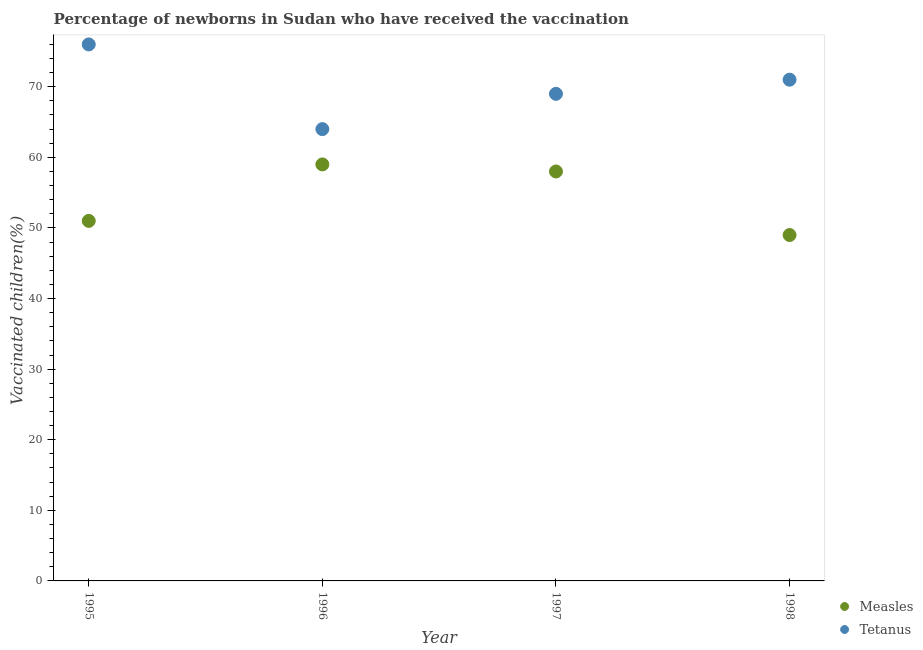Is the number of dotlines equal to the number of legend labels?
Offer a very short reply. Yes. What is the percentage of newborns who received vaccination for measles in 1997?
Make the answer very short. 58. Across all years, what is the maximum percentage of newborns who received vaccination for tetanus?
Give a very brief answer. 76. Across all years, what is the minimum percentage of newborns who received vaccination for tetanus?
Keep it short and to the point. 64. What is the total percentage of newborns who received vaccination for measles in the graph?
Your answer should be very brief. 217. What is the difference between the percentage of newborns who received vaccination for tetanus in 1995 and that in 1997?
Make the answer very short. 7. What is the difference between the percentage of newborns who received vaccination for tetanus in 1997 and the percentage of newborns who received vaccination for measles in 1998?
Offer a very short reply. 20. What is the average percentage of newborns who received vaccination for tetanus per year?
Offer a terse response. 70. In the year 1996, what is the difference between the percentage of newborns who received vaccination for measles and percentage of newborns who received vaccination for tetanus?
Ensure brevity in your answer.  -5. What is the ratio of the percentage of newborns who received vaccination for tetanus in 1997 to that in 1998?
Your answer should be compact. 0.97. Is the percentage of newborns who received vaccination for measles in 1995 less than that in 1998?
Provide a succinct answer. No. Is the difference between the percentage of newborns who received vaccination for tetanus in 1996 and 1998 greater than the difference between the percentage of newborns who received vaccination for measles in 1996 and 1998?
Your answer should be compact. No. What is the difference between the highest and the second highest percentage of newborns who received vaccination for measles?
Make the answer very short. 1. What is the difference between the highest and the lowest percentage of newborns who received vaccination for measles?
Give a very brief answer. 10. Is the percentage of newborns who received vaccination for tetanus strictly less than the percentage of newborns who received vaccination for measles over the years?
Offer a very short reply. No. How many years are there in the graph?
Provide a succinct answer. 4. Are the values on the major ticks of Y-axis written in scientific E-notation?
Your answer should be very brief. No. Where does the legend appear in the graph?
Your answer should be very brief. Bottom right. What is the title of the graph?
Offer a terse response. Percentage of newborns in Sudan who have received the vaccination. Does "Exports" appear as one of the legend labels in the graph?
Keep it short and to the point. No. What is the label or title of the X-axis?
Offer a terse response. Year. What is the label or title of the Y-axis?
Make the answer very short. Vaccinated children(%)
. What is the Vaccinated children(%)
 of Measles in 1995?
Offer a terse response. 51. What is the Vaccinated children(%)
 in Measles in 1996?
Ensure brevity in your answer.  59. What is the total Vaccinated children(%)
 of Measles in the graph?
Your response must be concise. 217. What is the total Vaccinated children(%)
 in Tetanus in the graph?
Keep it short and to the point. 280. What is the difference between the Vaccinated children(%)
 of Tetanus in 1995 and that in 1996?
Give a very brief answer. 12. What is the difference between the Vaccinated children(%)
 of Measles in 1995 and that in 1997?
Your answer should be compact. -7. What is the difference between the Vaccinated children(%)
 in Measles in 1995 and that in 1998?
Give a very brief answer. 2. What is the difference between the Vaccinated children(%)
 of Tetanus in 1996 and that in 1997?
Your answer should be compact. -5. What is the difference between the Vaccinated children(%)
 in Measles in 1996 and that in 1998?
Your response must be concise. 10. What is the difference between the Vaccinated children(%)
 in Tetanus in 1996 and that in 1998?
Your response must be concise. -7. What is the difference between the Vaccinated children(%)
 in Measles in 1997 and that in 1998?
Offer a terse response. 9. What is the difference between the Vaccinated children(%)
 of Tetanus in 1997 and that in 1998?
Provide a short and direct response. -2. What is the difference between the Vaccinated children(%)
 of Measles in 1995 and the Vaccinated children(%)
 of Tetanus in 1996?
Your response must be concise. -13. What is the difference between the Vaccinated children(%)
 of Measles in 1995 and the Vaccinated children(%)
 of Tetanus in 1997?
Provide a short and direct response. -18. What is the difference between the Vaccinated children(%)
 in Measles in 1995 and the Vaccinated children(%)
 in Tetanus in 1998?
Give a very brief answer. -20. What is the difference between the Vaccinated children(%)
 of Measles in 1996 and the Vaccinated children(%)
 of Tetanus in 1997?
Provide a short and direct response. -10. What is the average Vaccinated children(%)
 in Measles per year?
Your answer should be compact. 54.25. In the year 1996, what is the difference between the Vaccinated children(%)
 in Measles and Vaccinated children(%)
 in Tetanus?
Offer a terse response. -5. What is the ratio of the Vaccinated children(%)
 of Measles in 1995 to that in 1996?
Your response must be concise. 0.86. What is the ratio of the Vaccinated children(%)
 of Tetanus in 1995 to that in 1996?
Make the answer very short. 1.19. What is the ratio of the Vaccinated children(%)
 of Measles in 1995 to that in 1997?
Keep it short and to the point. 0.88. What is the ratio of the Vaccinated children(%)
 of Tetanus in 1995 to that in 1997?
Give a very brief answer. 1.1. What is the ratio of the Vaccinated children(%)
 of Measles in 1995 to that in 1998?
Make the answer very short. 1.04. What is the ratio of the Vaccinated children(%)
 of Tetanus in 1995 to that in 1998?
Ensure brevity in your answer.  1.07. What is the ratio of the Vaccinated children(%)
 of Measles in 1996 to that in 1997?
Your answer should be very brief. 1.02. What is the ratio of the Vaccinated children(%)
 in Tetanus in 1996 to that in 1997?
Provide a short and direct response. 0.93. What is the ratio of the Vaccinated children(%)
 in Measles in 1996 to that in 1998?
Provide a short and direct response. 1.2. What is the ratio of the Vaccinated children(%)
 of Tetanus in 1996 to that in 1998?
Give a very brief answer. 0.9. What is the ratio of the Vaccinated children(%)
 of Measles in 1997 to that in 1998?
Ensure brevity in your answer.  1.18. What is the ratio of the Vaccinated children(%)
 in Tetanus in 1997 to that in 1998?
Keep it short and to the point. 0.97. What is the difference between the highest and the second highest Vaccinated children(%)
 in Tetanus?
Provide a succinct answer. 5. 